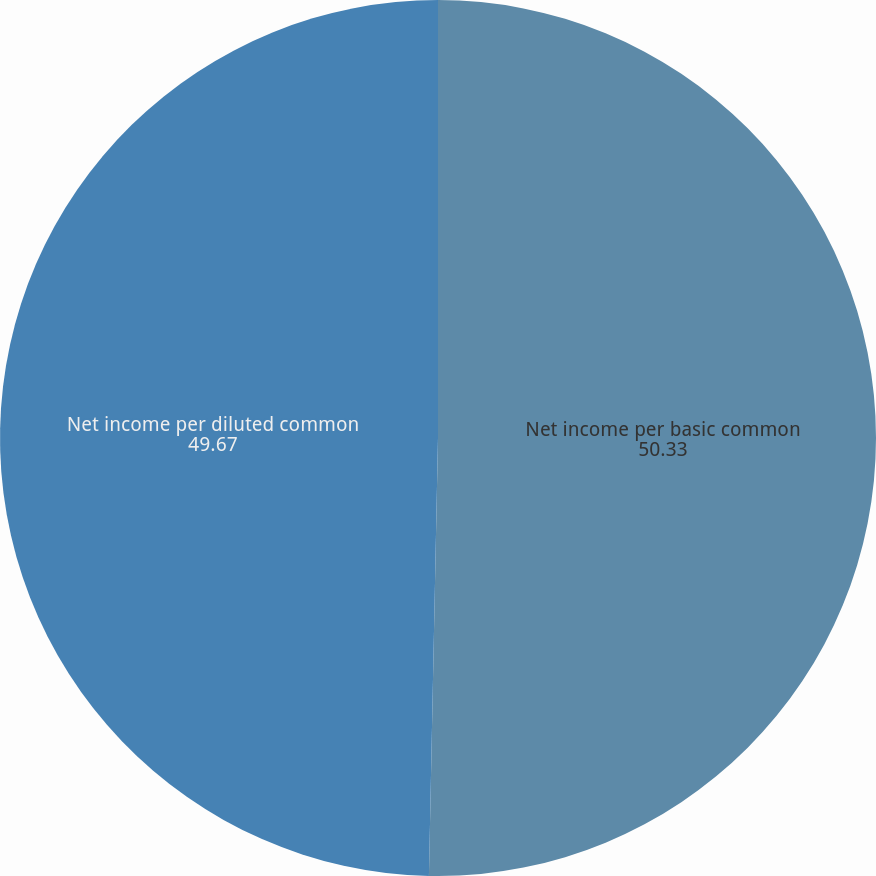Convert chart. <chart><loc_0><loc_0><loc_500><loc_500><pie_chart><fcel>Net income per basic common<fcel>Net income per diluted common<nl><fcel>50.33%<fcel>49.67%<nl></chart> 